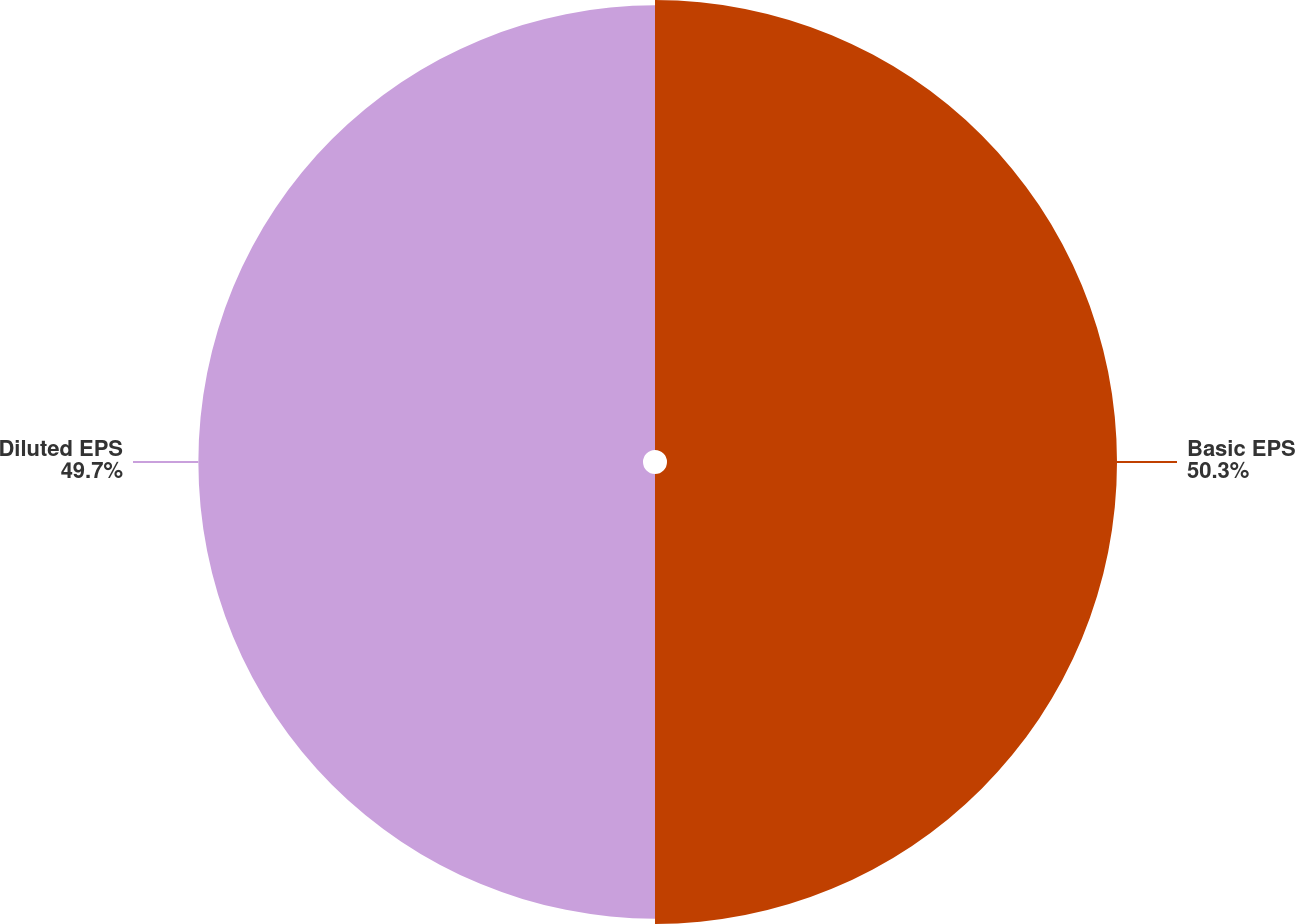<chart> <loc_0><loc_0><loc_500><loc_500><pie_chart><fcel>Basic EPS<fcel>Diluted EPS<nl><fcel>50.3%<fcel>49.7%<nl></chart> 